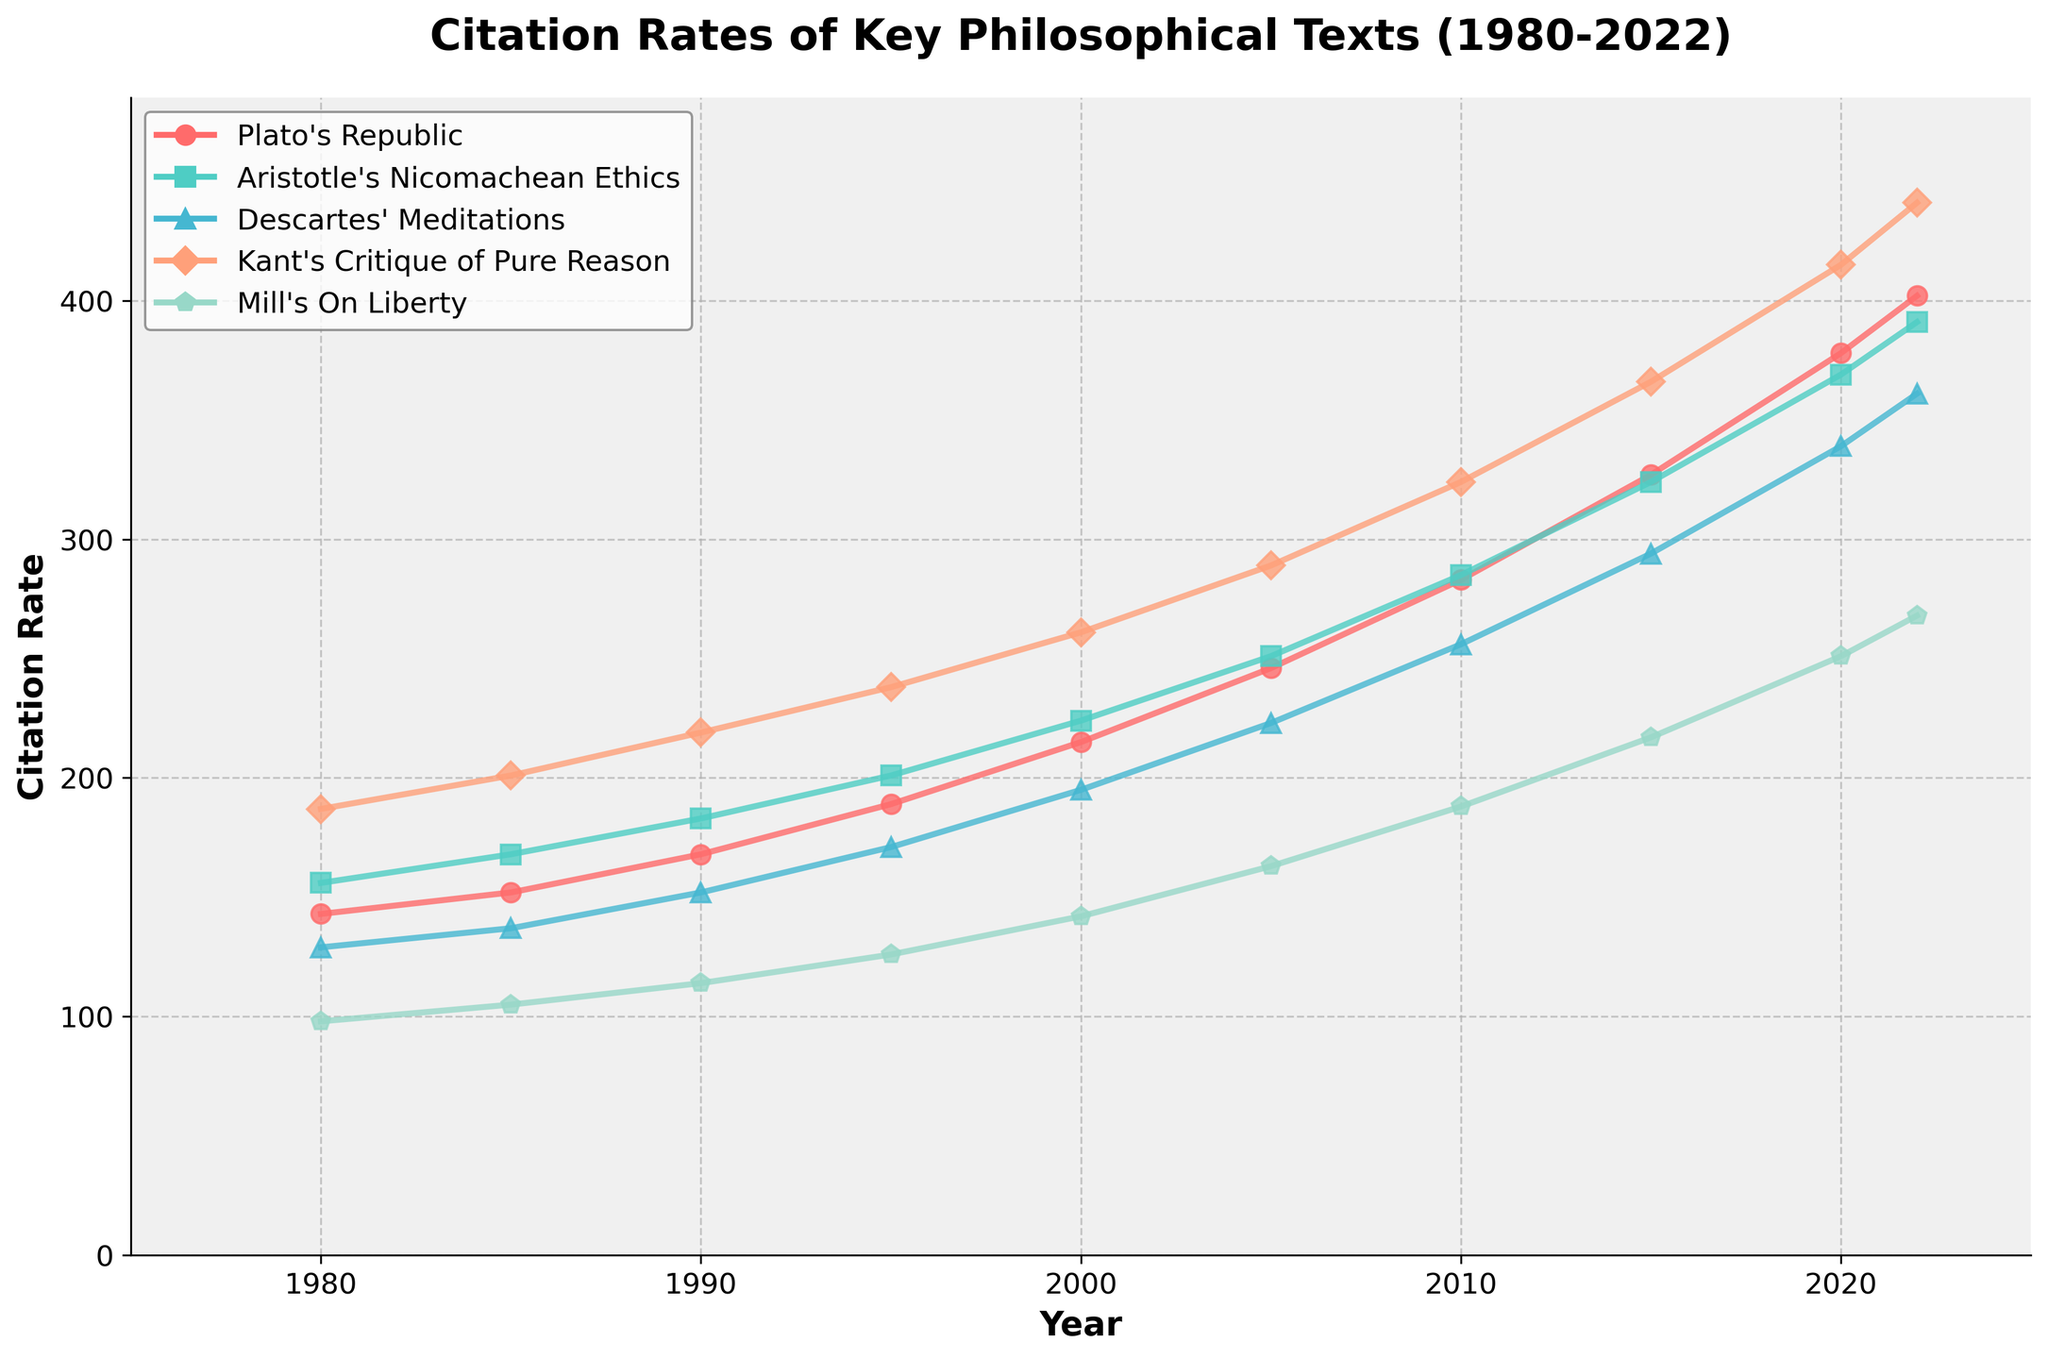Which philosophical text had the highest citation rate in 1980? To determine the highest citation rate for 1980, observe the citation rates of each text at the year 1980. The Critique of Pure Reason by Kant has the highest citation rate of 187 among the given texts for that year.
Answer: Critique of Pure Reason Between 1980 and 2022, by how much did the citation rate for Plato's Republic increase? Find the citation rate for Plato's Republic in both 1980 and 2022, then calculate the difference: 402 (2022) - 143 (1980) = 259.
Answer: 259 What is the average citation rate for Aristotle's Nicomachean Ethics between 1980 and 2022? Add the citation rates from 1980 to 2022 and divide by the number of data points (10): (156 + 168 + 183 + 201 + 224 + 251 + 285 + 324 + 369 + 391) / 10 = 255.2.
Answer: 255.2 In which year did Mill's On Liberty surpass 200 citations? Locate the year where Mill's On Liberty citation rate is first above 200. This occurs in 2015 with a citation rate of 217.
Answer: 2015 Which text showed the most consistent growth in citation rates over the observed period? Consistently growing citation rates can be observed by analyzing the trend lines. Kant's Critique of Pure Reason shows a consistent upward trend in citations over the entire period.
Answer: Critique of Pure Reason How does the citation rate difference between Descartes' Meditations and Mill's On Liberty in 2022 compare to their difference in 1980? Calculate the differences: For 1980, 129 (Meditations) - 98 (On Liberty) = 31. For 2022, 361 (Meditations) - 268 (On Liberty) = 93. The difference increased from 31 to 93.
Answer: Increased by 62 Between 2000 and 2020, which text had the highest increase in citations? Calculate the difference for each text between 2000 and 2020, then identify the highest: Plato's Republic (378 - 215 = 163), Nicomachean Ethics (369 - 224 = 145), Meditations (339 - 195 = 144), Critique of Pure Reason (415 - 261 = 154), On Liberty (251 - 142 = 109). The Republic shows the highest increase of 163.
Answer: Plato's Republic What is the combined citation rate for all texts in 1995? Sum the citation rates for each text in 1995: 189 (Republic) + 201 (Ethics) + 171 (Meditations) + 238 (Critique) + 126 (Liberty) = 925.
Answer: 925 Which text had the least variability in citation rates over the observed years? Calculate the range (difference between max and min) for each: Plato's Republic (402-143=259), Nicomachean Ethics (391-156=235), Meditations (361-129=232), Critique of Pure Reason (441-187=254), On Liberty (268-98=170). The least variability is in Mill's On Liberty with a range of 170.
Answer: On Liberty 